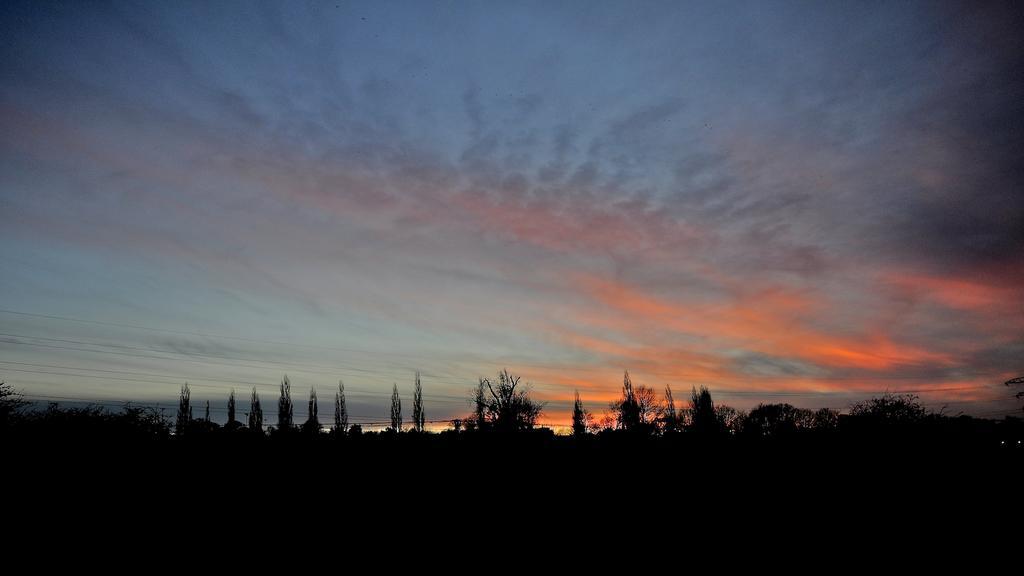Can you describe this image briefly? In this image we can see a group of trees and cloudy sky. 